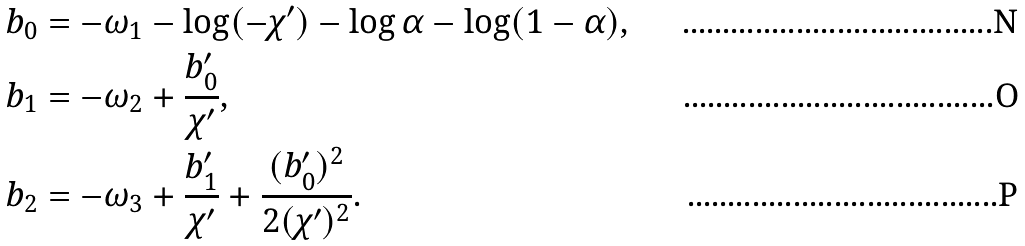Convert formula to latex. <formula><loc_0><loc_0><loc_500><loc_500>b _ { 0 } & = - \omega _ { 1 } - \log ( - \chi ^ { \prime } ) - \log \alpha - \log ( 1 - \alpha ) , \\ b _ { 1 } & = - \omega _ { 2 } + \frac { b _ { 0 } ^ { \prime } } { \chi ^ { \prime } } , \\ b _ { 2 } & = - \omega _ { 3 } + \frac { b _ { 1 } ^ { \prime } } { \chi ^ { \prime } } + \frac { ( b _ { 0 } ^ { \prime } ) ^ { 2 } } { 2 ( \chi ^ { \prime } ) ^ { 2 } } .</formula> 